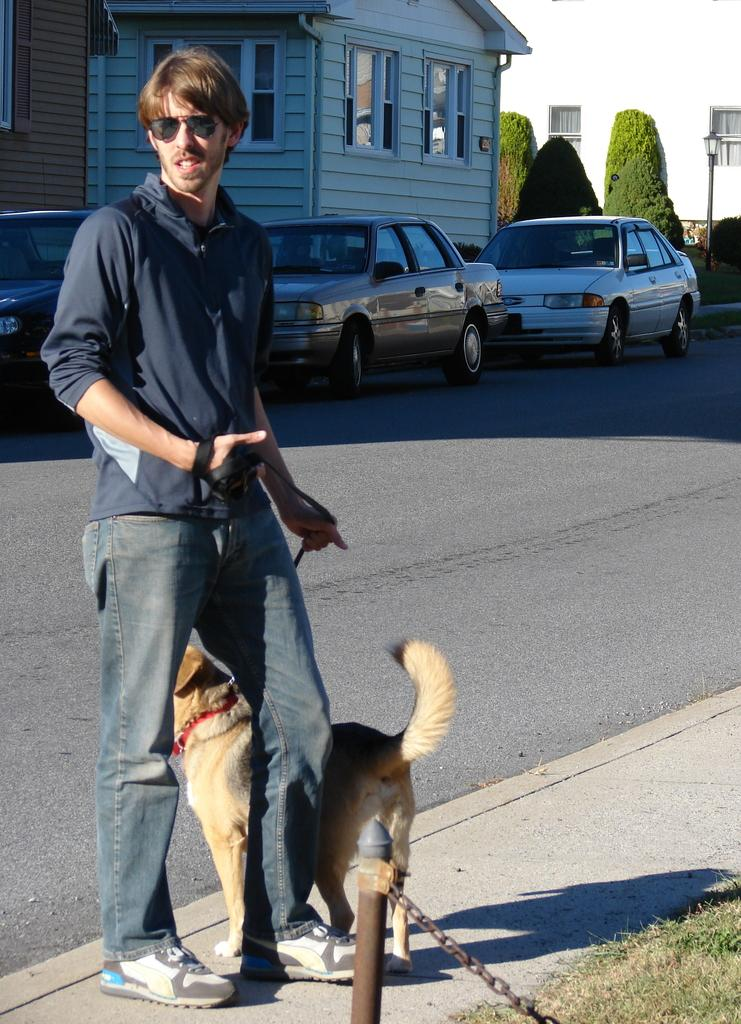What is the man on the left side of the image doing? The man is standing on the left side of the image and holding a dog tie. What can be seen on the right side of the image? There is a road, cars, and trees on the right side of the image. How many cars are visible in the image? There are cars visible in the image, but the exact number is not specified. What type of vegetation is present on the right side of the image? There are trees on the right side of the image. Can you tell me how many rays are visible in the image? There are no rays visible in the image. What type of bird is sitting on the man's knee in the image? There is no bird sitting on the man's knee in the image. 